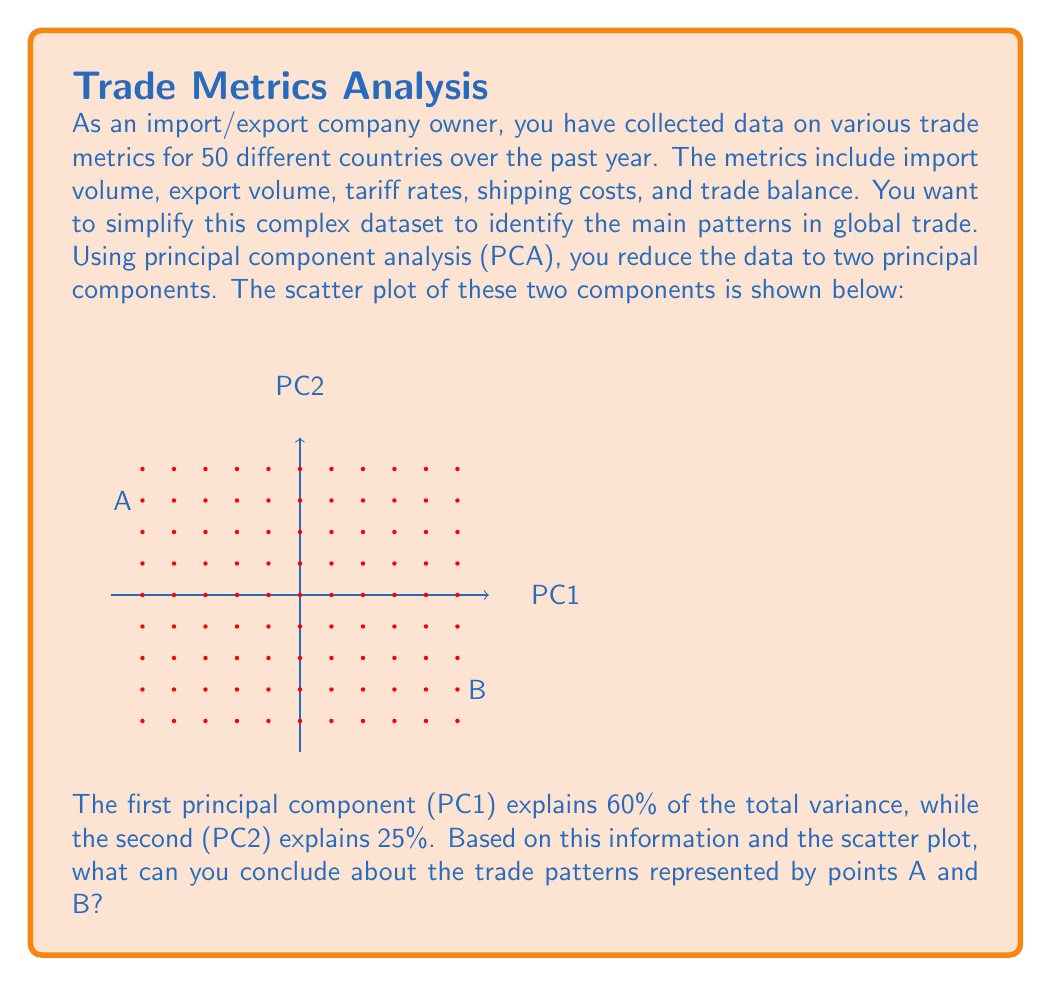Could you help me with this problem? To answer this question, we need to interpret the principal components and the scatter plot in the context of trade patterns. Let's break it down step by step:

1. Understanding PCA:
   Principal Component Analysis (PCA) is a technique used to reduce the dimensionality of a dataset while retaining most of its variability. The principal components are linear combinations of the original variables that capture the most variance in the data.

2. Interpreting the variance explained:
   - PC1 explains 60% of the total variance
   - PC2 explains 25% of the total variance
   - Together, they explain 85% of the total variance, which is a significant portion of the information in the original dataset

3. Interpreting the scatter plot:
   - The x-axis represents PC1, which captures the most variance (60%)
   - The y-axis represents PC2, which captures the second most variance (25%)
   - Each point on the plot represents a country's trade metrics projected onto these two principal components

4. Analyzing points A and B:
   - Point A is located at approximately (-2, 1.5) on the PC1-PC2 plane
   - Point B is located at approximately (2, -1.5) on the PC1-PC2 plane
   - These points are on opposite ends of the diagonal, suggesting they represent contrasting trade patterns

5. Interpreting the trade patterns:
   - PC1, being the most significant component, likely represents overall trade activity (e.g., combined import and export volumes)
   - PC2 might represent trade balance or other distinguishing factors between countries

6. Conclusions about points A and B:
   - Point A: Low score on PC1, high score on PC2
     This could represent a country with relatively low overall trade volume but a positive trade balance (more exports than imports)
   - Point B: High score on PC1, low score on PC2
     This could represent a country with high overall trade volume but a negative trade balance (more imports than exports)

Therefore, points A and B likely represent countries with contrasting trade patterns: A having lower trade volume but a trade surplus, and B having higher trade volume but a trade deficit.
Answer: A: Low trade volume, trade surplus; B: High trade volume, trade deficit 